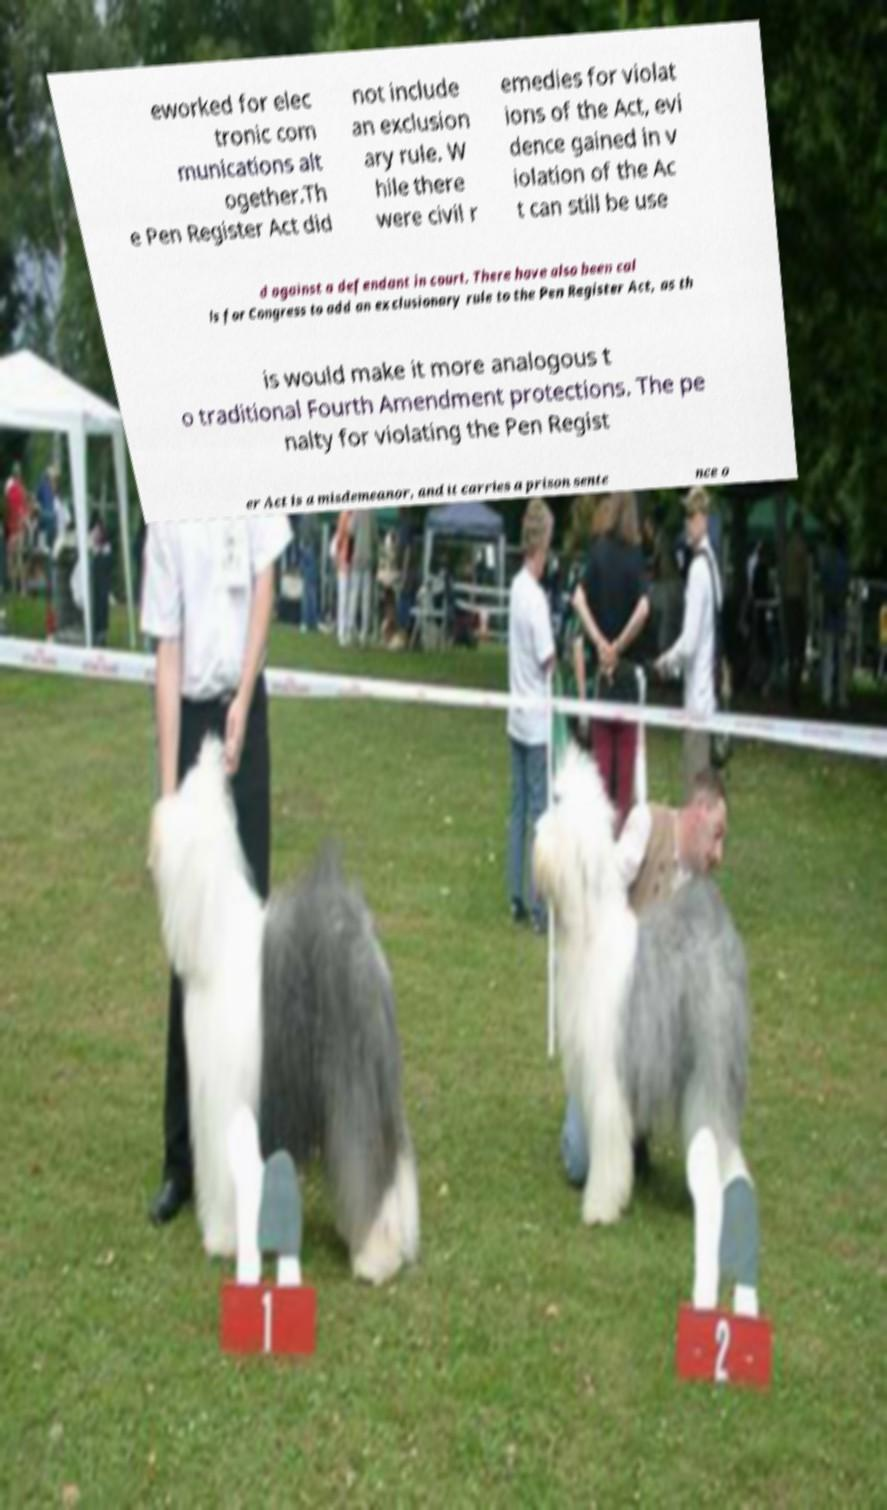Could you extract and type out the text from this image? eworked for elec tronic com munications alt ogether.Th e Pen Register Act did not include an exclusion ary rule. W hile there were civil r emedies for violat ions of the Act, evi dence gained in v iolation of the Ac t can still be use d against a defendant in court. There have also been cal ls for Congress to add an exclusionary rule to the Pen Register Act, as th is would make it more analogous t o traditional Fourth Amendment protections. The pe nalty for violating the Pen Regist er Act is a misdemeanor, and it carries a prison sente nce o 